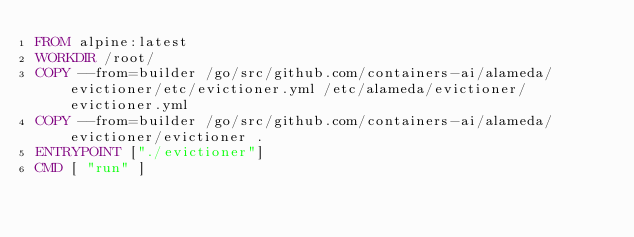Convert code to text. <code><loc_0><loc_0><loc_500><loc_500><_Dockerfile_>FROM alpine:latest
WORKDIR /root/
COPY --from=builder /go/src/github.com/containers-ai/alameda/evictioner/etc/evictioner.yml /etc/alameda/evictioner/evictioner.yml
COPY --from=builder /go/src/github.com/containers-ai/alameda/evictioner/evictioner .
ENTRYPOINT ["./evictioner"]
CMD [ "run" ]
</code> 